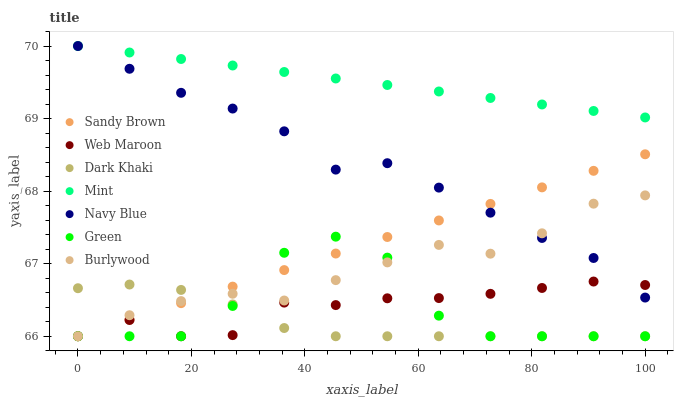Does Dark Khaki have the minimum area under the curve?
Answer yes or no. Yes. Does Mint have the maximum area under the curve?
Answer yes or no. Yes. Does Web Maroon have the minimum area under the curve?
Answer yes or no. No. Does Web Maroon have the maximum area under the curve?
Answer yes or no. No. Is Mint the smoothest?
Answer yes or no. Yes. Is Green the roughest?
Answer yes or no. Yes. Is Web Maroon the smoothest?
Answer yes or no. No. Is Web Maroon the roughest?
Answer yes or no. No. Does Burlywood have the lowest value?
Answer yes or no. Yes. Does Mint have the lowest value?
Answer yes or no. No. Does Navy Blue have the highest value?
Answer yes or no. Yes. Does Web Maroon have the highest value?
Answer yes or no. No. Is Dark Khaki less than Navy Blue?
Answer yes or no. Yes. Is Navy Blue greater than Green?
Answer yes or no. Yes. Does Dark Khaki intersect Sandy Brown?
Answer yes or no. Yes. Is Dark Khaki less than Sandy Brown?
Answer yes or no. No. Is Dark Khaki greater than Sandy Brown?
Answer yes or no. No. Does Dark Khaki intersect Navy Blue?
Answer yes or no. No. 